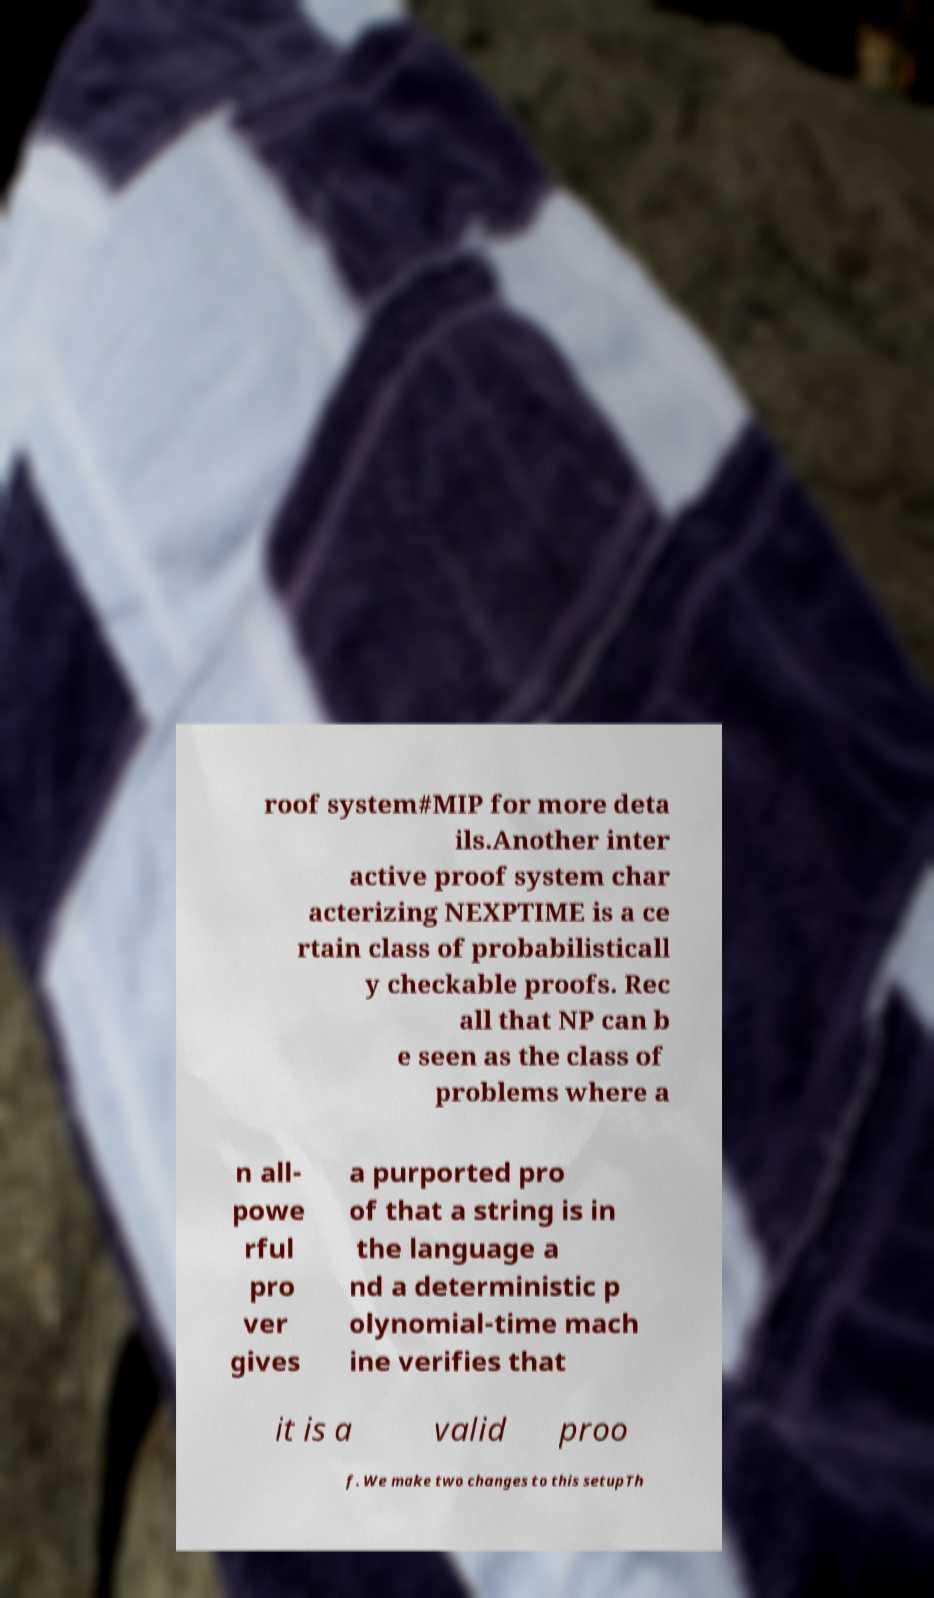Please identify and transcribe the text found in this image. roof system#MIP for more deta ils.Another inter active proof system char acterizing NEXPTIME is a ce rtain class of probabilisticall y checkable proofs. Rec all that NP can b e seen as the class of problems where a n all- powe rful pro ver gives a purported pro of that a string is in the language a nd a deterministic p olynomial-time mach ine verifies that it is a valid proo f. We make two changes to this setupTh 